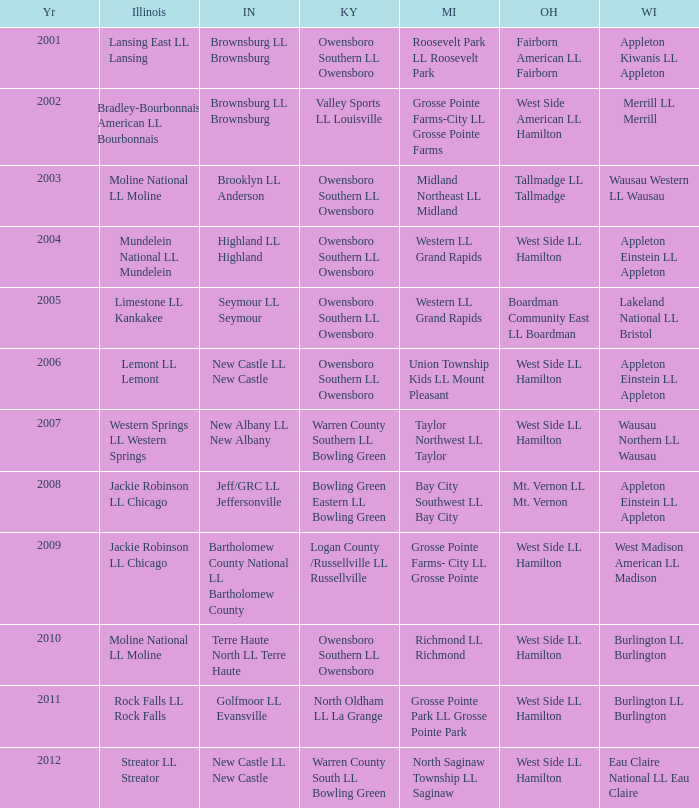What was the little league team from Ohio when the little league team from Kentucky was Warren County South LL Bowling Green? West Side LL Hamilton. 